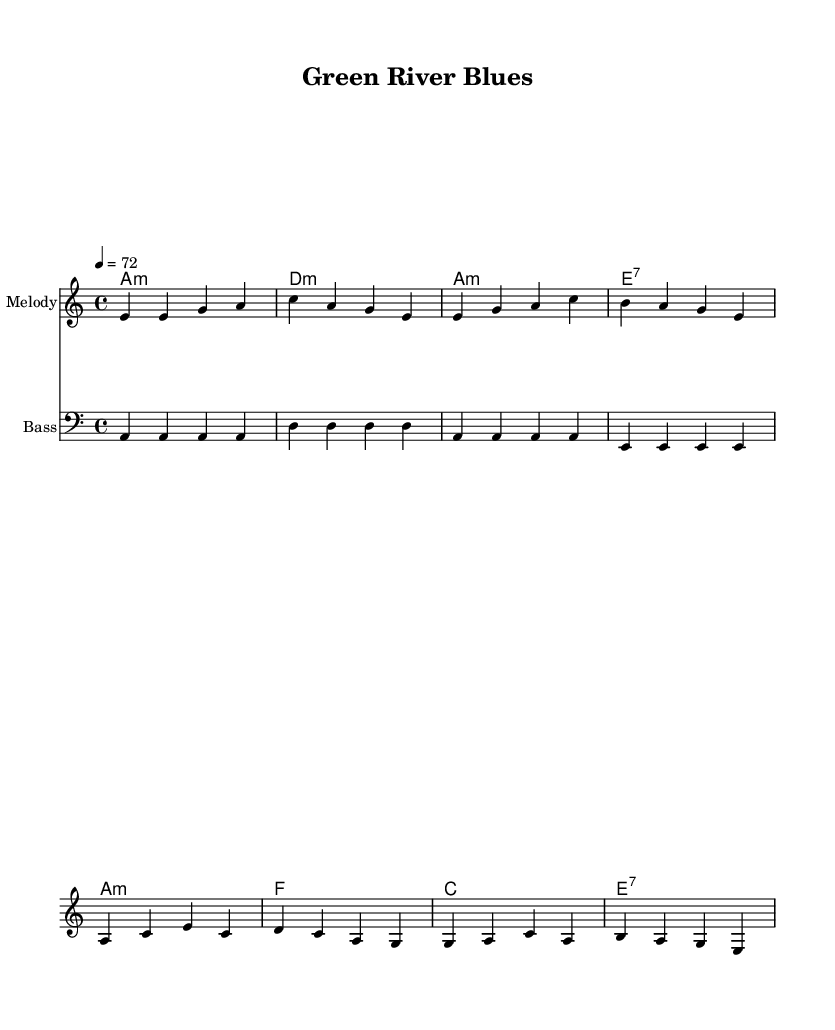What is the key signature of this music? The key signature is A minor, which has no sharps or flats.
Answer: A minor What is the time signature of this piece? The time signature is 4/4, meaning there are four beats per measure.
Answer: 4/4 What is the tempo marking of the piece? The tempo marking indicates a tempo of 72 beats per minute, which is moderate.
Answer: 72 How many measures are in the verse melody? The verse melody consists of 4 measures, as indicated by the grouping of notes.
Answer: 4 What type of chords are played in the verse? The chords in the verse are minor and seventh chords, typical for blues music.
Answer: Minor and seventh What is the emotional theme conveyed in the lyrics? The lyrics convey themes of environmental concern and the urgency for a sustainable future.
Answer: Environmental concern What is the primary genre of this music? The primary genre is electric blues, characterized by its soulful expression and focus on sustainability in the lyrics.
Answer: Electric blues 